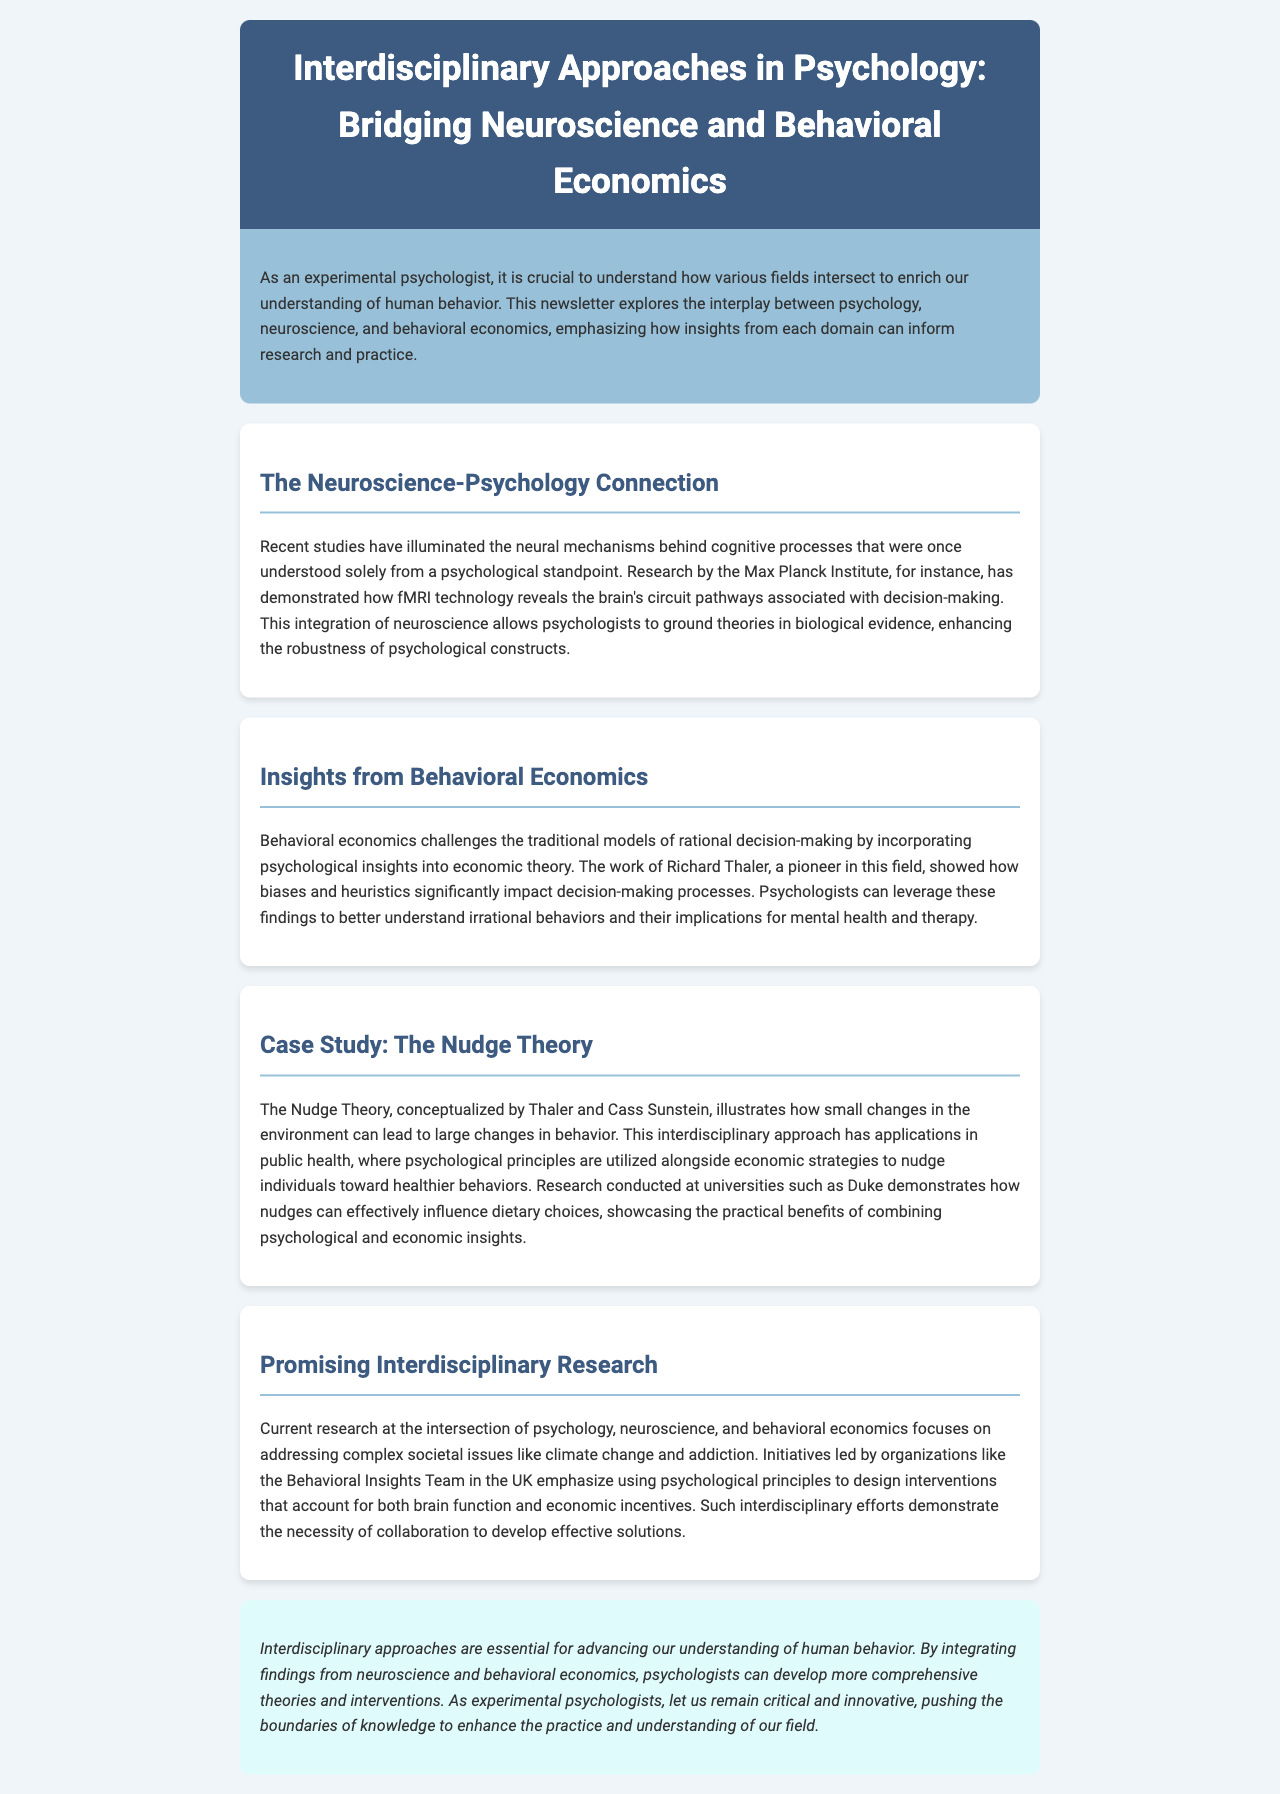What is the focus of this newsletter? The newsletter focuses on the interplay between psychology, neuroscience, and behavioral economics.
Answer: Interdisciplinary approaches Which institute is mentioned for its neuroscience research? The newsletter states that the Max Planck Institute has conducted research demonstrating neural mechanisms behind cognitive processes.
Answer: Max Planck Institute Who is a pioneer in behavioral economics mentioned in the document? Richard Thaler is cited as a pioneer in behavioral economics, showing how biases impact decision-making.
Answer: Richard Thaler What theory is discussed in relation to small behavior changes? The Nudge Theory illustrates how environmental changes can lead to large behavioral changes.
Answer: Nudge Theory Which university conducted research related to the Nudge Theory? Duke University is mentioned as the institution where research on nudges influencing dietary choices was conducted.
Answer: Duke What societal issues are current interdisciplinary research addressing? The document highlights that current research focuses on complex issues like climate change and addiction.
Answer: Climate change and addiction What is the role of the Behavioral Insights Team mentioned? The Behavioral Insights Team designs interventions that consider brain function and economic incentives.
Answer: Design interventions What is emphasized as essential for advancing understanding of human behavior? The conclusion emphasizes that interdisciplinary approaches are essential for advancing understanding in psychology.
Answer: Interdisciplinary approaches 